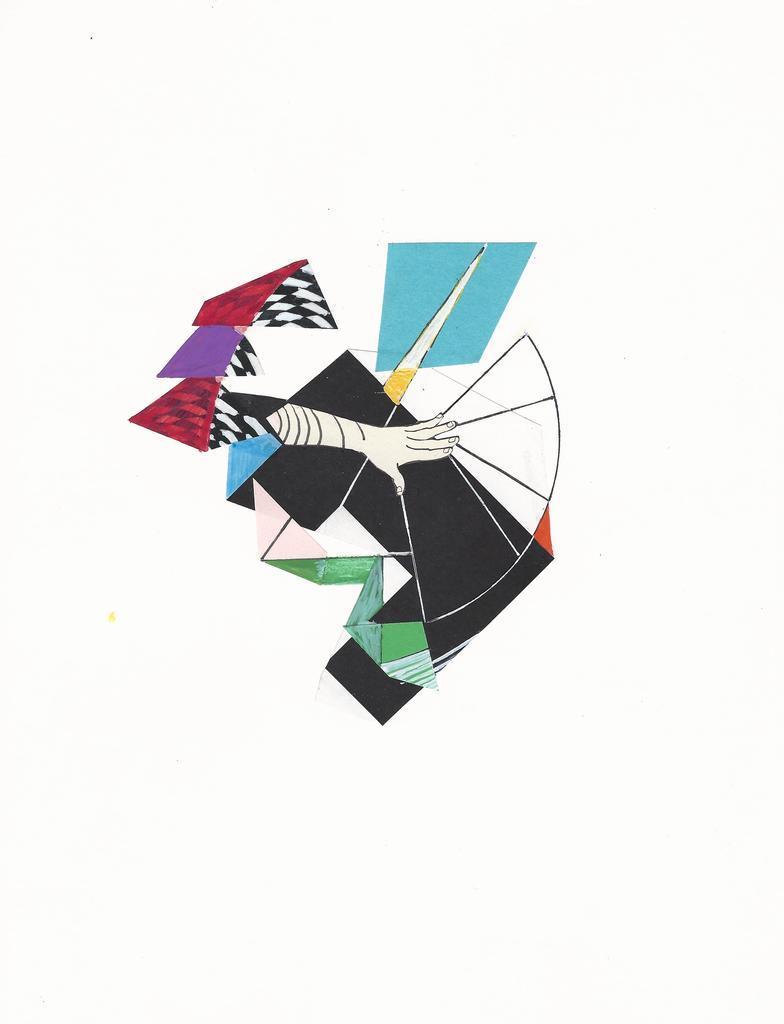In one or two sentences, can you explain what this image depicts? In this picture I can see painting which is colorful and I can see a hand and I see the white color background. 